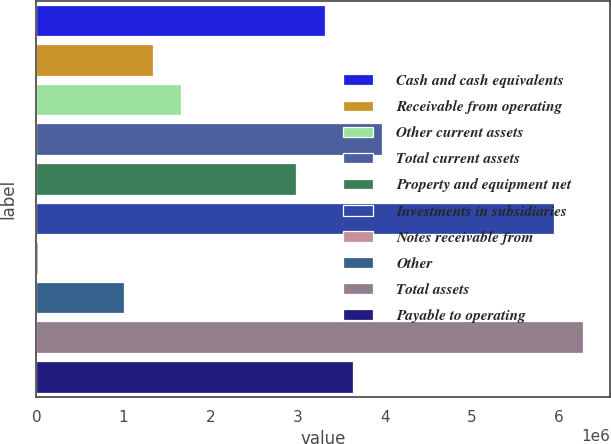Convert chart. <chart><loc_0><loc_0><loc_500><loc_500><bar_chart><fcel>Cash and cash equivalents<fcel>Receivable from operating<fcel>Other current assets<fcel>Total current assets<fcel>Property and equipment net<fcel>Investments in subsidiaries<fcel>Notes receivable from<fcel>Other<fcel>Total assets<fcel>Payable to operating<nl><fcel>3.30682e+06<fcel>1.33293e+06<fcel>1.66191e+06<fcel>3.96478e+06<fcel>2.97783e+06<fcel>5.93867e+06<fcel>17000<fcel>1.00394e+06<fcel>6.26765e+06<fcel>3.6358e+06<nl></chart> 